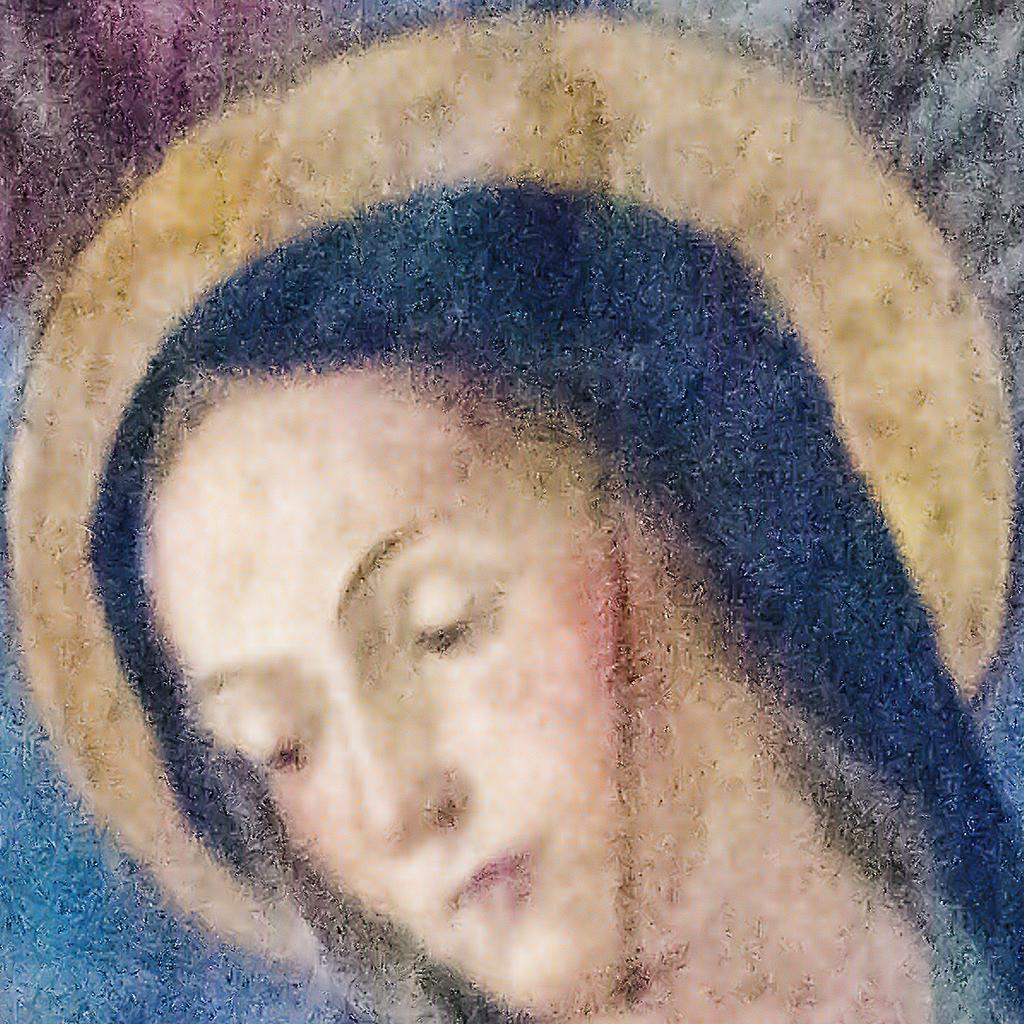What type of artwork is depicted in the image? The image is a painting. Who or what is the main subject of the painting? There is a woman in the painting. What can be seen in the background of the painting? There is a moon in the background of the painting. What type of cake is being served at the woman's home in the painting? There is no mention of a home or cake in the painting; it features a woman and a moon in the background. 